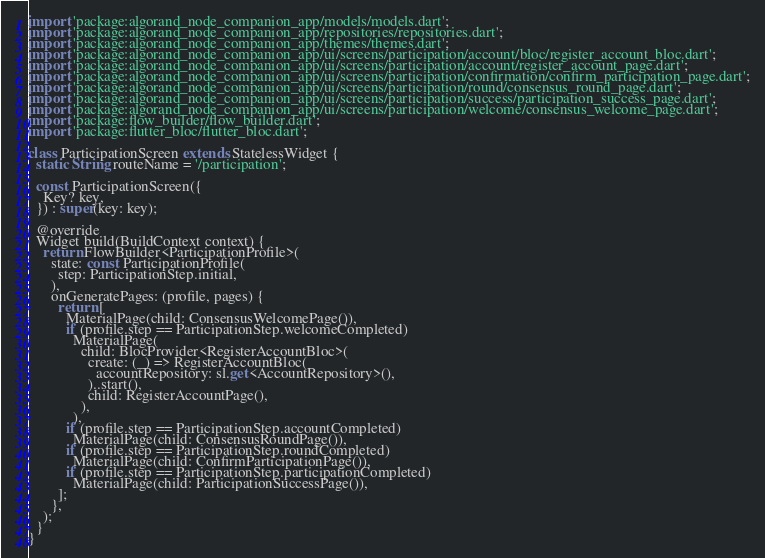Convert code to text. <code><loc_0><loc_0><loc_500><loc_500><_Dart_>import 'package:algorand_node_companion_app/models/models.dart';
import 'package:algorand_node_companion_app/repositories/repositories.dart';
import 'package:algorand_node_companion_app/themes/themes.dart';
import 'package:algorand_node_companion_app/ui/screens/participation/account/bloc/register_account_bloc.dart';
import 'package:algorand_node_companion_app/ui/screens/participation/account/register_account_page.dart';
import 'package:algorand_node_companion_app/ui/screens/participation/confirmation/confirm_participation_page.dart';
import 'package:algorand_node_companion_app/ui/screens/participation/round/consensus_round_page.dart';
import 'package:algorand_node_companion_app/ui/screens/participation/success/participation_success_page.dart';
import 'package:algorand_node_companion_app/ui/screens/participation/welcome/consensus_welcome_page.dart';
import 'package:flow_builder/flow_builder.dart';
import 'package:flutter_bloc/flutter_bloc.dart';

class ParticipationScreen extends StatelessWidget {
  static String routeName = '/participation';

  const ParticipationScreen({
    Key? key,
  }) : super(key: key);

  @override
  Widget build(BuildContext context) {
    return FlowBuilder<ParticipationProfile>(
      state: const ParticipationProfile(
        step: ParticipationStep.initial,
      ),
      onGeneratePages: (profile, pages) {
        return [
          MaterialPage(child: ConsensusWelcomePage()),
          if (profile.step == ParticipationStep.welcomeCompleted)
            MaterialPage(
              child: BlocProvider<RegisterAccountBloc>(
                create: (_) => RegisterAccountBloc(
                  accountRepository: sl.get<AccountRepository>(),
                )..start(),
                child: RegisterAccountPage(),
              ),
            ),
          if (profile.step == ParticipationStep.accountCompleted)
            MaterialPage(child: ConsensusRoundPage()),
          if (profile.step == ParticipationStep.roundCompleted)
            MaterialPage(child: ConfirmParticipationPage()),
          if (profile.step == ParticipationStep.participationCompleted)
            MaterialPage(child: ParticipationSuccessPage()),
        ];
      },
    );
  }
}
</code> 